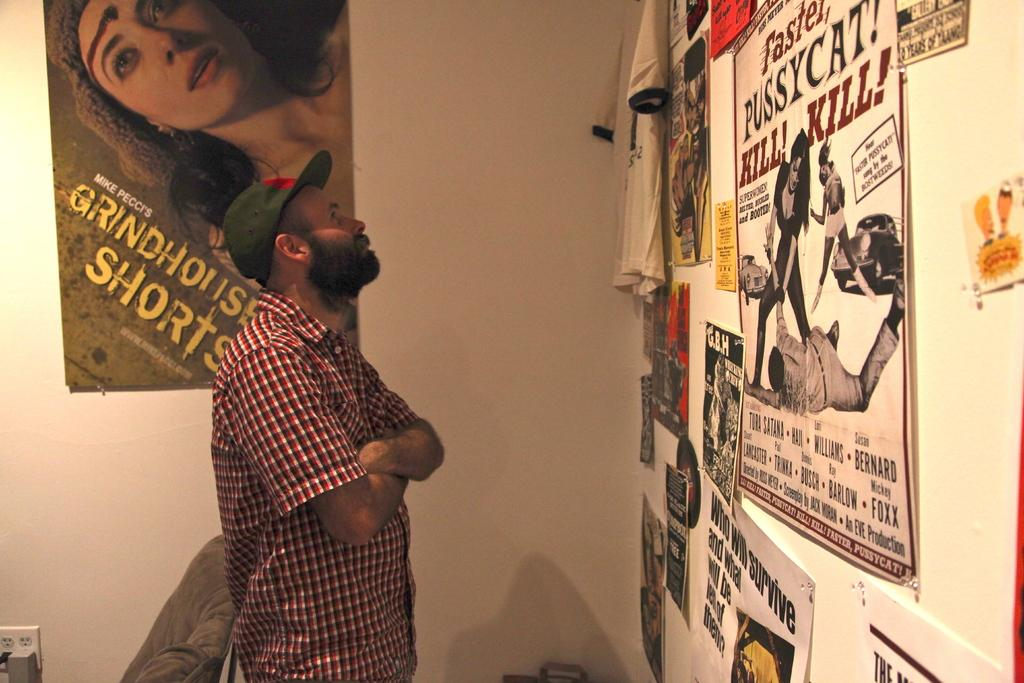What is the main subject in the image? There is a man standing in the image. What object can be seen near the man? There is a chair in the image. What is on the walls in the image? There are posters and a T-shirt attached to the walls. What type of basin is used for washing hands in the image? There is no basin present in the image. How does the sleet affect the man's clothing in the image? There is no sleet present in the image, so it cannot affect the man's clothing. 